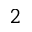Convert formula to latex. <formula><loc_0><loc_0><loc_500><loc_500>_ { 2 }</formula> 